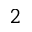Convert formula to latex. <formula><loc_0><loc_0><loc_500><loc_500>_ { 2 }</formula> 